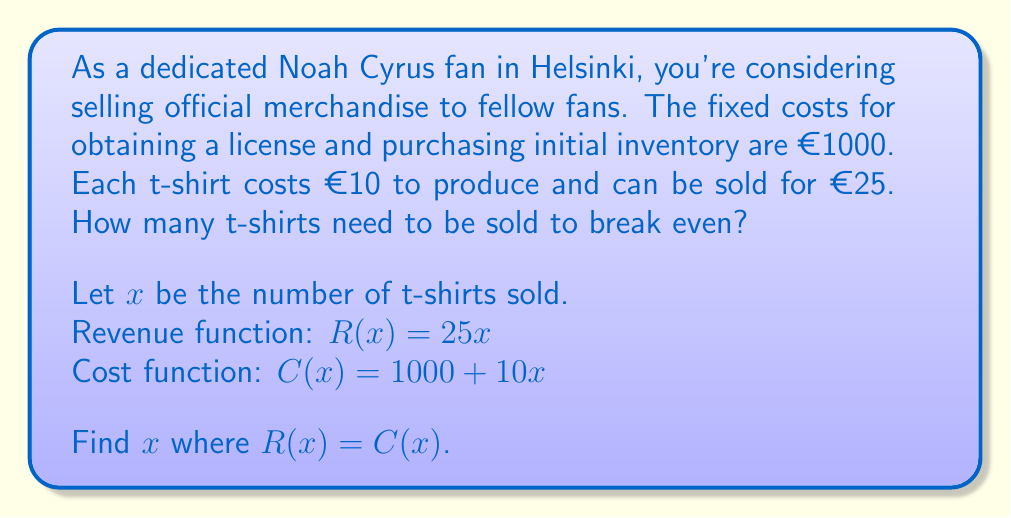Can you solve this math problem? To find the break-even point, we need to determine where the revenue equals the costs. Let's solve this step-by-step:

1. Set up the equation:
   $R(x) = C(x)$
   $25x = 1000 + 10x$

2. Subtract $10x$ from both sides:
   $15x = 1000$

3. Divide both sides by 15:
   $x = \frac{1000}{15}$

4. Simplify the fraction:
   $x = 66.\overline{6}$

Since we can't sell a fraction of a t-shirt, we need to round up to the nearest whole number.

The break-even point occurs when 67 t-shirts are sold.

To verify:
Revenue: $R(67) = 25 \times 67 = 1675$
Costs: $C(67) = 1000 + 10 \times 67 = 1670$

At 67 t-shirts, revenue slightly exceeds costs, confirming the break-even point.
Answer: 67 t-shirts 